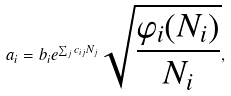Convert formula to latex. <formula><loc_0><loc_0><loc_500><loc_500>a _ { i } = b _ { i } e ^ { \sum _ { j } c _ { i j } N _ { j } } \sqrt { \frac { \varphi _ { i } ( N _ { i } ) } { N _ { i } } } ,</formula> 